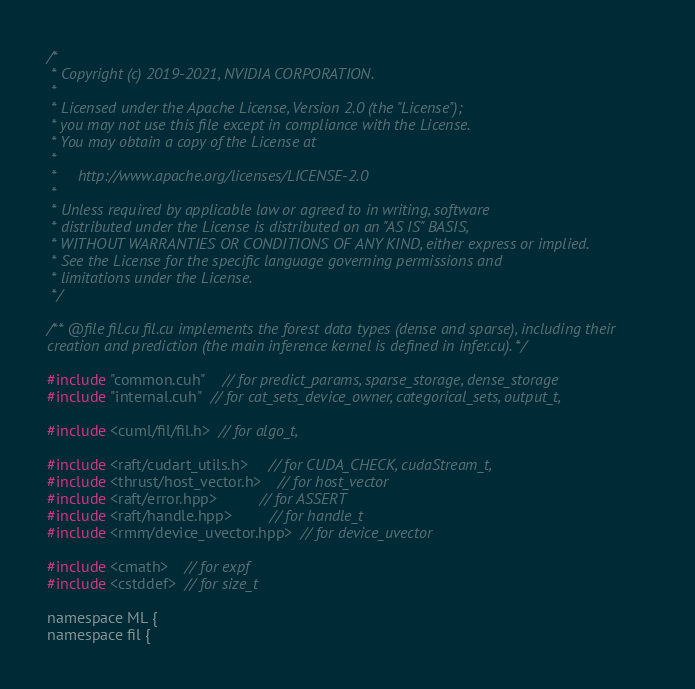Convert code to text. <code><loc_0><loc_0><loc_500><loc_500><_Cuda_>/*
 * Copyright (c) 2019-2021, NVIDIA CORPORATION.
 *
 * Licensed under the Apache License, Version 2.0 (the "License");
 * you may not use this file except in compliance with the License.
 * You may obtain a copy of the License at
 *
 *     http://www.apache.org/licenses/LICENSE-2.0
 *
 * Unless required by applicable law or agreed to in writing, software
 * distributed under the License is distributed on an "AS IS" BASIS,
 * WITHOUT WARRANTIES OR CONDITIONS OF ANY KIND, either express or implied.
 * See the License for the specific language governing permissions and
 * limitations under the License.
 */

/** @file fil.cu fil.cu implements the forest data types (dense and sparse), including their
creation and prediction (the main inference kernel is defined in infer.cu). */

#include "common.cuh"    // for predict_params, sparse_storage, dense_storage
#include "internal.cuh"  // for cat_sets_device_owner, categorical_sets, output_t,

#include <cuml/fil/fil.h>  // for algo_t,

#include <raft/cudart_utils.h>     // for CUDA_CHECK, cudaStream_t,
#include <thrust/host_vector.h>    // for host_vector
#include <raft/error.hpp>          // for ASSERT
#include <raft/handle.hpp>         // for handle_t
#include <rmm/device_uvector.hpp>  // for device_uvector

#include <cmath>    // for expf
#include <cstddef>  // for size_t

namespace ML {
namespace fil {
</code> 